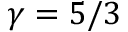Convert formula to latex. <formula><loc_0><loc_0><loc_500><loc_500>\gamma = 5 / 3</formula> 